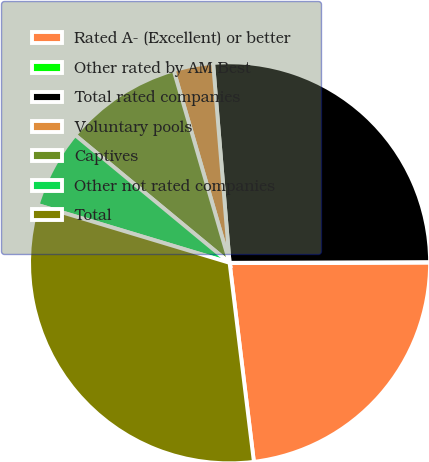Convert chart. <chart><loc_0><loc_0><loc_500><loc_500><pie_chart><fcel>Rated A- (Excellent) or better<fcel>Other rated by AM Best<fcel>Total rated companies<fcel>Voluntary pools<fcel>Captives<fcel>Other not rated companies<fcel>Total<nl><fcel>23.09%<fcel>0.03%<fcel>26.25%<fcel>3.19%<fcel>9.5%<fcel>6.34%<fcel>31.59%<nl></chart> 